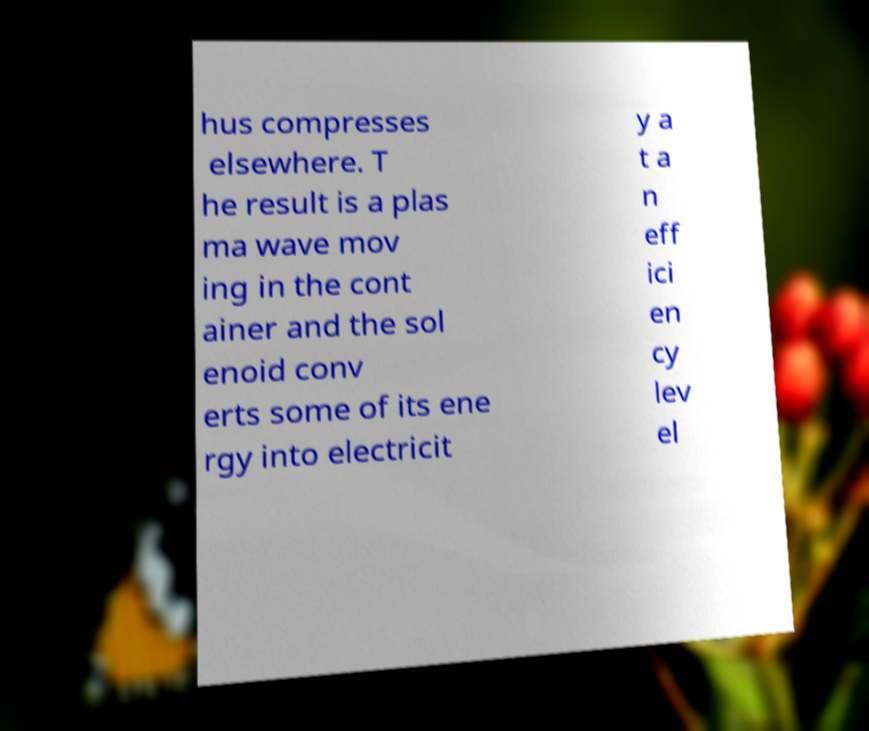Can you read and provide the text displayed in the image?This photo seems to have some interesting text. Can you extract and type it out for me? hus compresses elsewhere. T he result is a plas ma wave mov ing in the cont ainer and the sol enoid conv erts some of its ene rgy into electricit y a t a n eff ici en cy lev el 